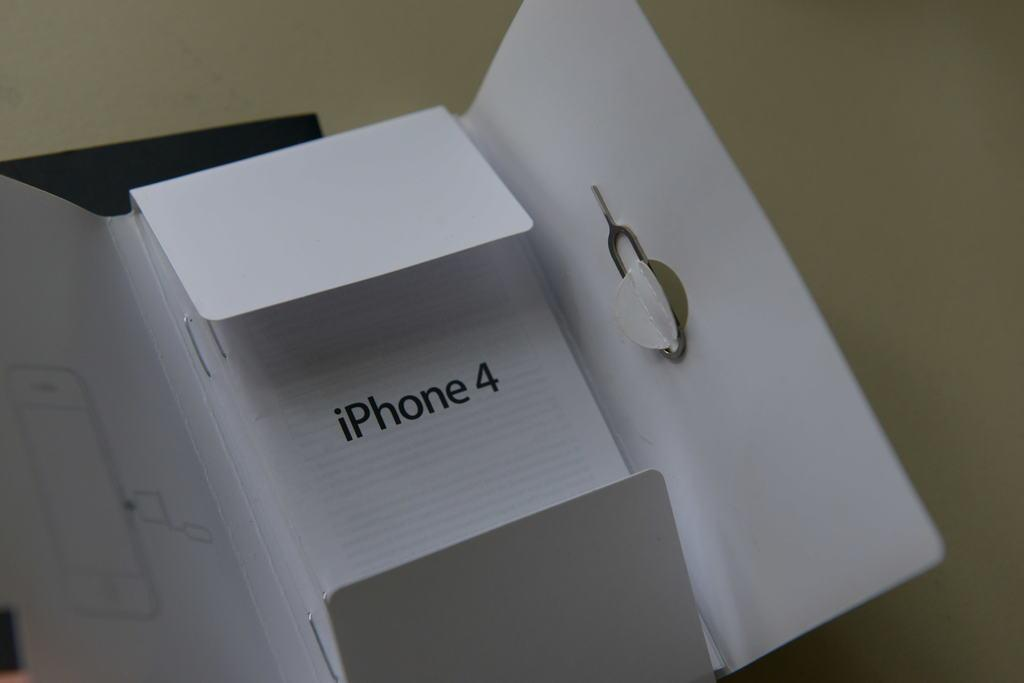Provide a one-sentence caption for the provided image. A box for the iPhone4 is open on a table. 